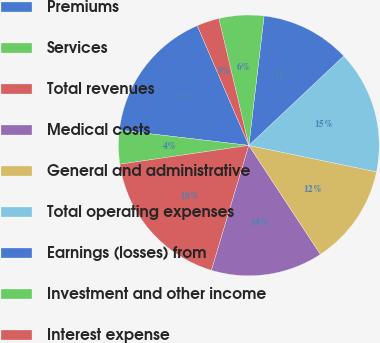<chart> <loc_0><loc_0><loc_500><loc_500><pie_chart><fcel>Premiums<fcel>Services<fcel>Total revenues<fcel>Medical costs<fcel>General and administrative<fcel>Total operating expenses<fcel>Earnings (losses) from<fcel>Investment and other income<fcel>Interest expense<nl><fcel>16.67%<fcel>4.17%<fcel>18.06%<fcel>13.89%<fcel>12.5%<fcel>15.28%<fcel>11.11%<fcel>5.56%<fcel>2.78%<nl></chart> 